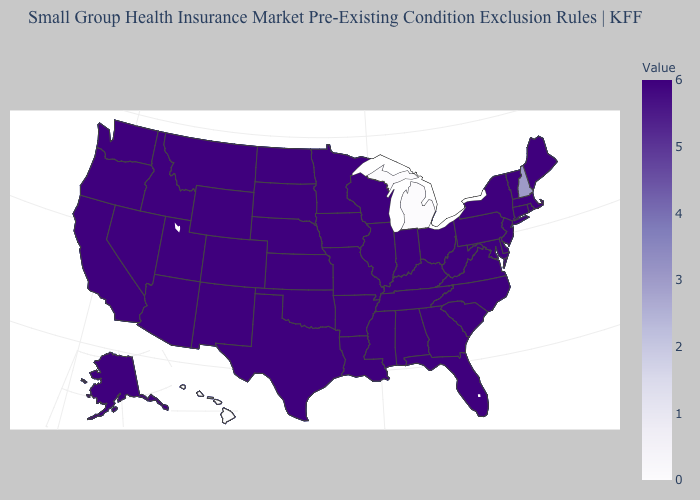Which states hav the highest value in the MidWest?
Be succinct. Illinois, Indiana, Iowa, Kansas, Minnesota, Missouri, Nebraska, North Dakota, Ohio, South Dakota, Wisconsin. Does the map have missing data?
Short answer required. No. Does Oregon have a lower value than New Hampshire?
Quick response, please. No. 